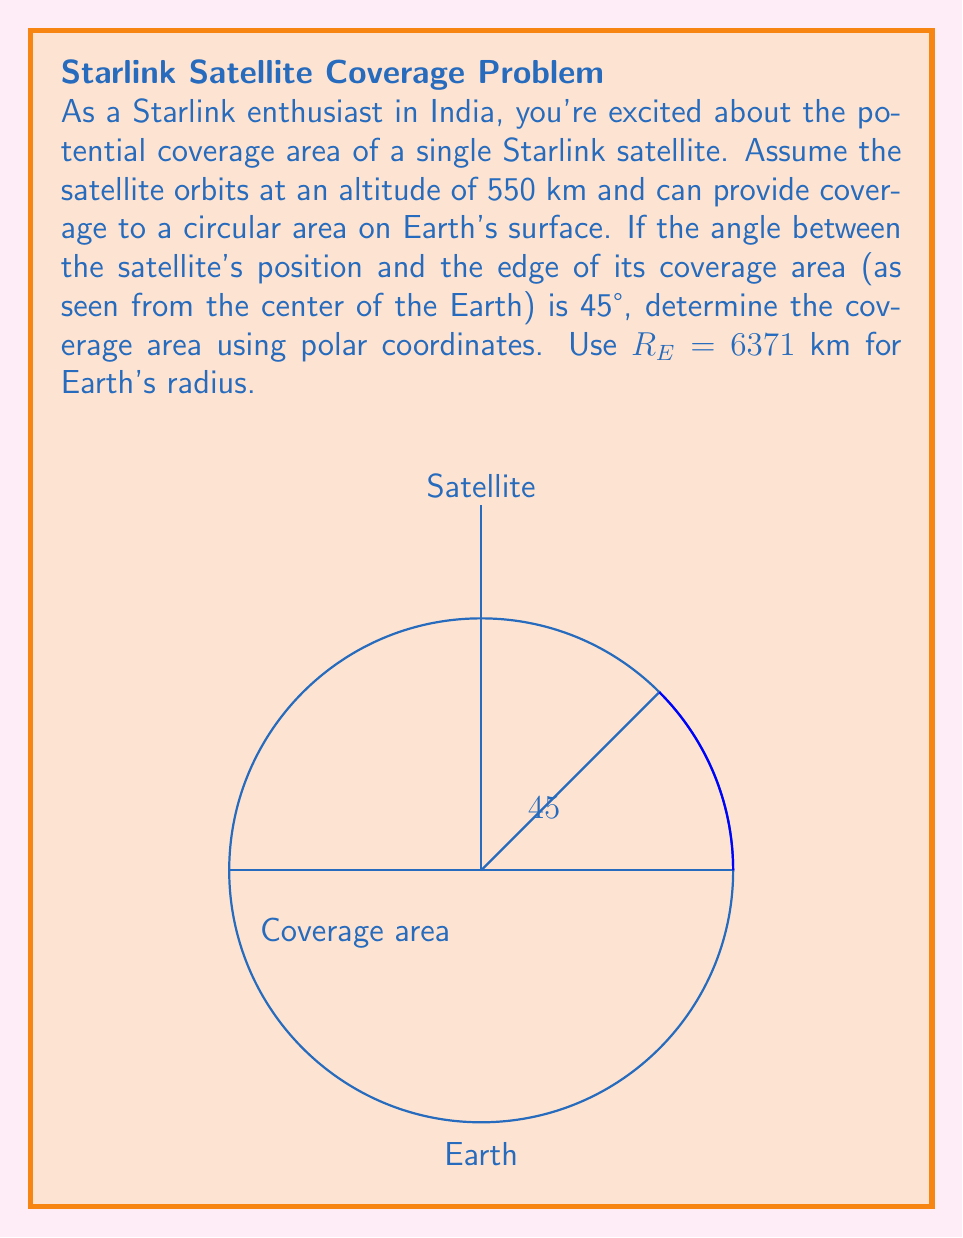Show me your answer to this math problem. Let's approach this step-by-step:

1) First, we need to find the radius of the coverage area on Earth's surface. We can do this using the law of sines in the triangle formed by the Earth's center, the satellite, and the edge of the coverage area.

2) Let $r$ be the radius of the coverage area. In the triangle:
   $$\frac{\sin(45°)}{R_E} = \frac{\sin(90°)}{R_E + 550}$$

3) Solving for $r$:
   $$r = R_E \sin(45°) = 6371 \cdot \frac{\sqrt{2}}{2} \approx 4505.97 \text{ km}$$

4) Now, we need to express this circular area in polar coordinates. The general equation for a circle in polar coordinates is:
   $$r(\theta) = a$$
   where $a$ is the radius of the circle.

5) In our case, $a = 4505.97 \text{ km}$, so the equation of our coverage area in polar coordinates is:
   $$r(\theta) = 4505.97, \quad 0 \leq \theta < 2\pi$$

6) To find the area, we use the formula for area in polar coordinates:
   $$A = \frac{1}{2} \int_0^{2\pi} [r(\theta)]^2 d\theta$$

7) Substituting our equation:
   $$A = \frac{1}{2} \int_0^{2\pi} (4505.97)^2 d\theta = \frac{1}{2} (4505.97)^2 \cdot 2\pi$$

8) Calculating:
   $$A = \pi (4505.97)^2 \approx 63,783,573 \text{ km}^2$$
Answer: $63,783,573 \text{ km}^2$ 